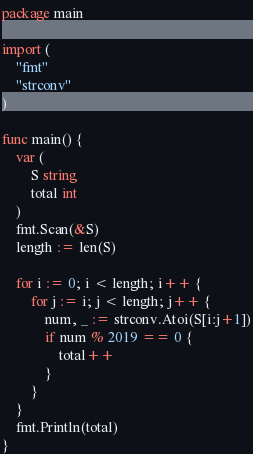<code> <loc_0><loc_0><loc_500><loc_500><_Go_>package main

import (
	"fmt"
	"strconv"
)

func main() {
	var (
		S string
		total int
	)
	fmt.Scan(&S)
	length := len(S)

	for i := 0; i < length; i++ {
		for j := i; j < length; j++ {
			num, _ := strconv.Atoi(S[i:j+1])
			if num % 2019 == 0 {
				total++
			}
		}
	}
	fmt.Println(total)
}</code> 